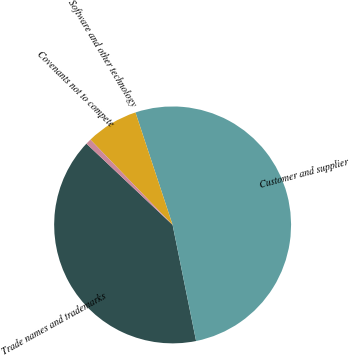Convert chart to OTSL. <chart><loc_0><loc_0><loc_500><loc_500><pie_chart><fcel>Trade names and trademarks<fcel>Customer and supplier<fcel>Software and other technology<fcel>Covenants not to compete<nl><fcel>40.21%<fcel>51.9%<fcel>7.13%<fcel>0.76%<nl></chart> 